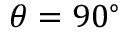<formula> <loc_0><loc_0><loc_500><loc_500>\theta = 9 0 ^ { \circ }</formula> 